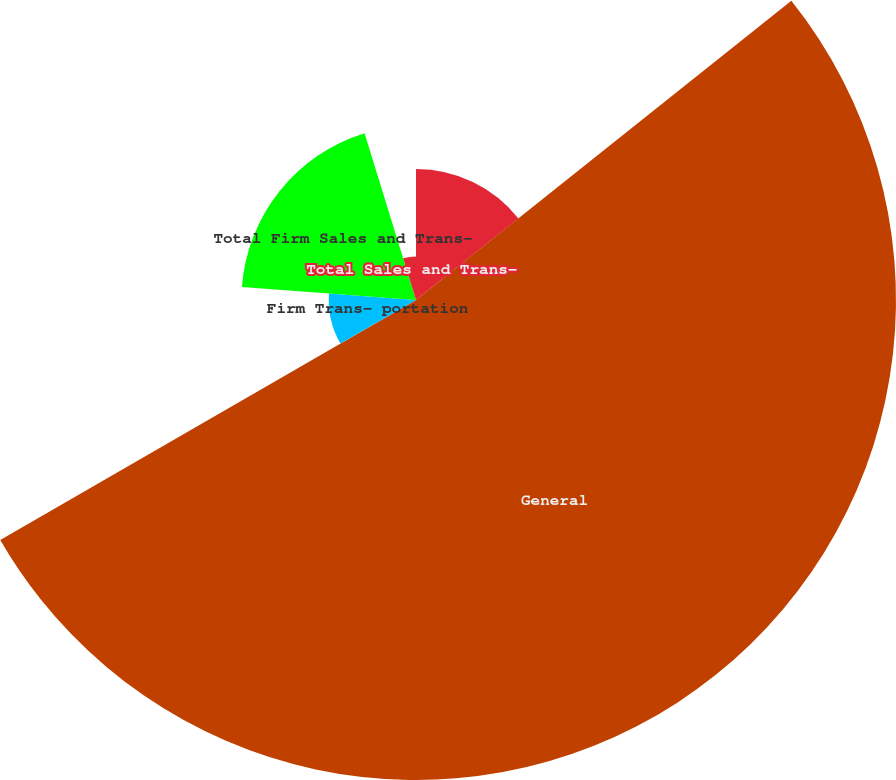<chart> <loc_0><loc_0><loc_500><loc_500><pie_chart><fcel>Residential<fcel>General<fcel>Firm Trans- portation<fcel>Total Firm Sales and Trans-<fcel>Total Sales and Trans-<nl><fcel>14.29%<fcel>52.38%<fcel>9.52%<fcel>19.05%<fcel>4.76%<nl></chart> 